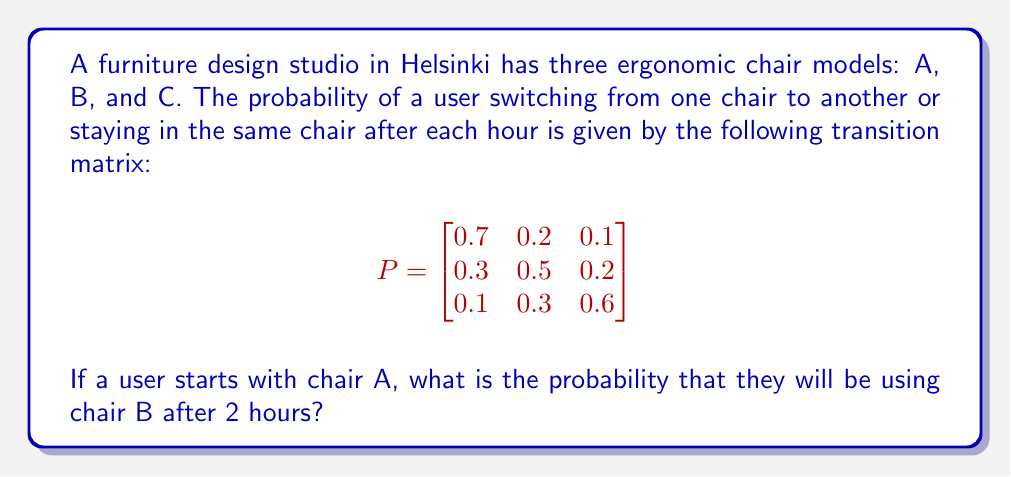Can you solve this math problem? To solve this problem, we'll use the Chapman-Kolmogorov equations and matrix multiplication:

1. The initial state vector is $v_0 = [1, 0, 0]$ since the user starts with chair A.

2. We need to calculate $P^2$ (the transition matrix raised to the power of 2) to find the probabilities after 2 hours:

   $$P^2 = P \times P = \begin{bmatrix}
   0.7 & 0.2 & 0.1 \\
   0.3 & 0.5 & 0.2 \\
   0.1 & 0.3 & 0.6
   \end{bmatrix} \times 
   \begin{bmatrix}
   0.7 & 0.2 & 0.1 \\
   0.3 & 0.5 & 0.2 \\
   0.1 & 0.3 & 0.6
   \end{bmatrix}$$

3. Performing the matrix multiplication:

   $$P^2 = \begin{bmatrix}
   0.56 & 0.27 & 0.17 \\
   0.40 & 0.37 & 0.23 \\
   0.22 & 0.36 & 0.42
   \end{bmatrix}$$

4. Now, we multiply the initial state vector by $P^2$:

   $$v_2 = v_0 \times P^2 = [1, 0, 0] \times 
   \begin{bmatrix}
   0.56 & 0.27 & 0.17 \\
   0.40 & 0.37 & 0.23 \\
   0.22 & 0.36 & 0.42
   \end{bmatrix}$$

5. The result is:

   $$v_2 = [0.56, 0.27, 0.17]$$

6. The probability of being in chair B after 2 hours is the second element of $v_2$, which is 0.27 or 27%.
Answer: 0.27 